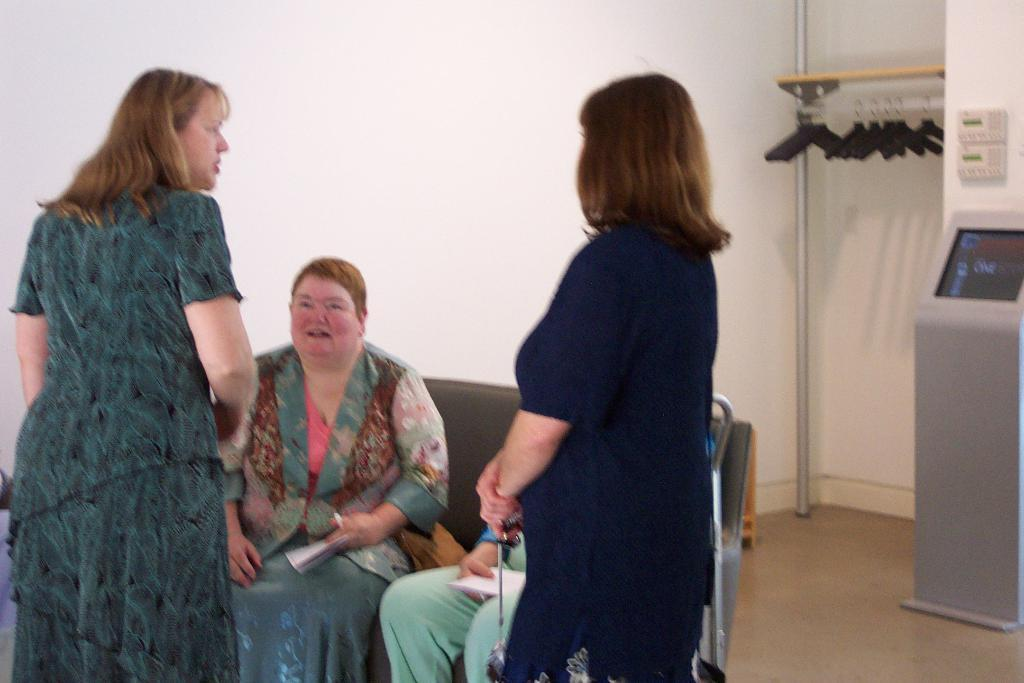What is the color of the wall in the image? The wall in the image is white. What feature can be found on the wall? There is a door in the image. What are the people in the image doing? Some of the people are sitting on a bench. What type of birds can be seen flying near the power wheel in the image? There are no birds or power wheels present in the image. 